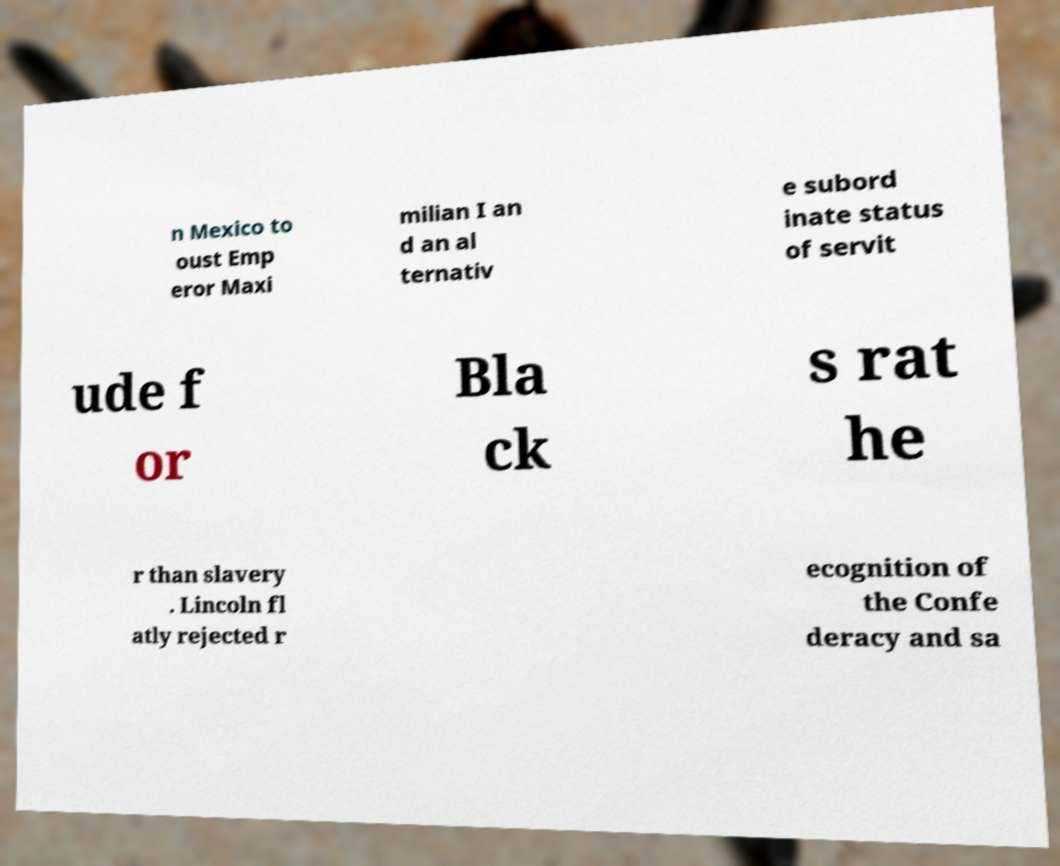Could you extract and type out the text from this image? n Mexico to oust Emp eror Maxi milian I an d an al ternativ e subord inate status of servit ude f or Bla ck s rat he r than slavery . Lincoln fl atly rejected r ecognition of the Confe deracy and sa 